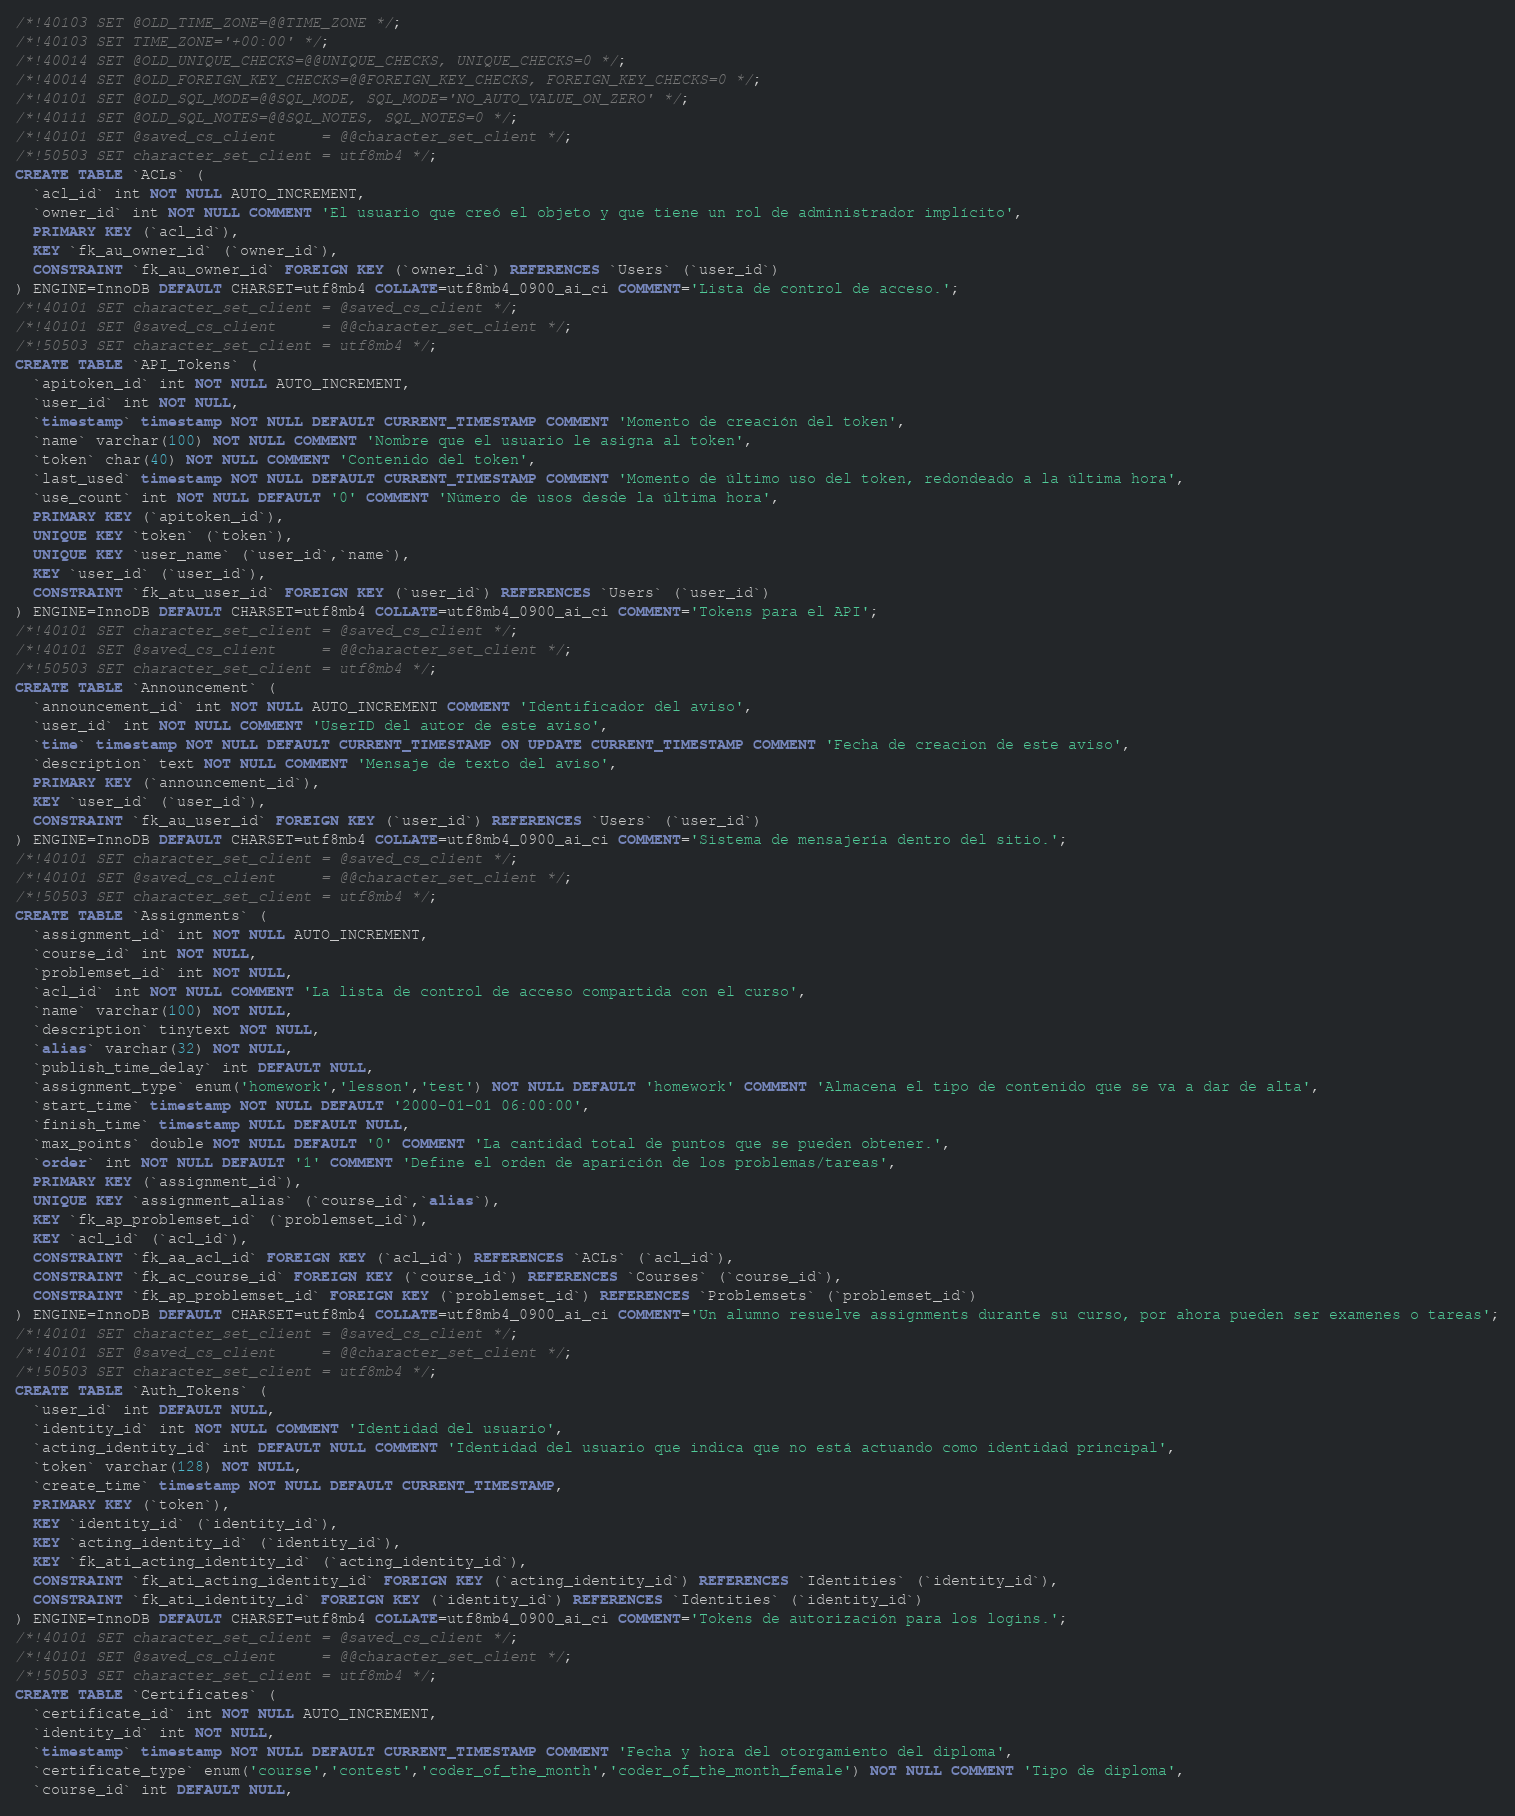Convert code to text. <code><loc_0><loc_0><loc_500><loc_500><_SQL_>/*!40103 SET @OLD_TIME_ZONE=@@TIME_ZONE */;
/*!40103 SET TIME_ZONE='+00:00' */;
/*!40014 SET @OLD_UNIQUE_CHECKS=@@UNIQUE_CHECKS, UNIQUE_CHECKS=0 */;
/*!40014 SET @OLD_FOREIGN_KEY_CHECKS=@@FOREIGN_KEY_CHECKS, FOREIGN_KEY_CHECKS=0 */;
/*!40101 SET @OLD_SQL_MODE=@@SQL_MODE, SQL_MODE='NO_AUTO_VALUE_ON_ZERO' */;
/*!40111 SET @OLD_SQL_NOTES=@@SQL_NOTES, SQL_NOTES=0 */;
/*!40101 SET @saved_cs_client     = @@character_set_client */;
/*!50503 SET character_set_client = utf8mb4 */;
CREATE TABLE `ACLs` (
  `acl_id` int NOT NULL AUTO_INCREMENT,
  `owner_id` int NOT NULL COMMENT 'El usuario que creó el objeto y que tiene un rol de administrador implícito',
  PRIMARY KEY (`acl_id`),
  KEY `fk_au_owner_id` (`owner_id`),
  CONSTRAINT `fk_au_owner_id` FOREIGN KEY (`owner_id`) REFERENCES `Users` (`user_id`)
) ENGINE=InnoDB DEFAULT CHARSET=utf8mb4 COLLATE=utf8mb4_0900_ai_ci COMMENT='Lista de control de acceso.';
/*!40101 SET character_set_client = @saved_cs_client */;
/*!40101 SET @saved_cs_client     = @@character_set_client */;
/*!50503 SET character_set_client = utf8mb4 */;
CREATE TABLE `API_Tokens` (
  `apitoken_id` int NOT NULL AUTO_INCREMENT,
  `user_id` int NOT NULL,
  `timestamp` timestamp NOT NULL DEFAULT CURRENT_TIMESTAMP COMMENT 'Momento de creación del token',
  `name` varchar(100) NOT NULL COMMENT 'Nombre que el usuario le asigna al token',
  `token` char(40) NOT NULL COMMENT 'Contenido del token',
  `last_used` timestamp NOT NULL DEFAULT CURRENT_TIMESTAMP COMMENT 'Momento de último uso del token, redondeado a la última hora',
  `use_count` int NOT NULL DEFAULT '0' COMMENT 'Número de usos desde la última hora',
  PRIMARY KEY (`apitoken_id`),
  UNIQUE KEY `token` (`token`),
  UNIQUE KEY `user_name` (`user_id`,`name`),
  KEY `user_id` (`user_id`),
  CONSTRAINT `fk_atu_user_id` FOREIGN KEY (`user_id`) REFERENCES `Users` (`user_id`)
) ENGINE=InnoDB DEFAULT CHARSET=utf8mb4 COLLATE=utf8mb4_0900_ai_ci COMMENT='Tokens para el API';
/*!40101 SET character_set_client = @saved_cs_client */;
/*!40101 SET @saved_cs_client     = @@character_set_client */;
/*!50503 SET character_set_client = utf8mb4 */;
CREATE TABLE `Announcement` (
  `announcement_id` int NOT NULL AUTO_INCREMENT COMMENT 'Identificador del aviso',
  `user_id` int NOT NULL COMMENT 'UserID del autor de este aviso',
  `time` timestamp NOT NULL DEFAULT CURRENT_TIMESTAMP ON UPDATE CURRENT_TIMESTAMP COMMENT 'Fecha de creacion de este aviso',
  `description` text NOT NULL COMMENT 'Mensaje de texto del aviso',
  PRIMARY KEY (`announcement_id`),
  KEY `user_id` (`user_id`),
  CONSTRAINT `fk_au_user_id` FOREIGN KEY (`user_id`) REFERENCES `Users` (`user_id`)
) ENGINE=InnoDB DEFAULT CHARSET=utf8mb4 COLLATE=utf8mb4_0900_ai_ci COMMENT='Sistema de mensajería dentro del sitio.';
/*!40101 SET character_set_client = @saved_cs_client */;
/*!40101 SET @saved_cs_client     = @@character_set_client */;
/*!50503 SET character_set_client = utf8mb4 */;
CREATE TABLE `Assignments` (
  `assignment_id` int NOT NULL AUTO_INCREMENT,
  `course_id` int NOT NULL,
  `problemset_id` int NOT NULL,
  `acl_id` int NOT NULL COMMENT 'La lista de control de acceso compartida con el curso',
  `name` varchar(100) NOT NULL,
  `description` tinytext NOT NULL,
  `alias` varchar(32) NOT NULL,
  `publish_time_delay` int DEFAULT NULL,
  `assignment_type` enum('homework','lesson','test') NOT NULL DEFAULT 'homework' COMMENT 'Almacena el tipo de contenido que se va a dar de alta',
  `start_time` timestamp NOT NULL DEFAULT '2000-01-01 06:00:00',
  `finish_time` timestamp NULL DEFAULT NULL,
  `max_points` double NOT NULL DEFAULT '0' COMMENT 'La cantidad total de puntos que se pueden obtener.',
  `order` int NOT NULL DEFAULT '1' COMMENT 'Define el orden de aparición de los problemas/tareas',
  PRIMARY KEY (`assignment_id`),
  UNIQUE KEY `assignment_alias` (`course_id`,`alias`),
  KEY `fk_ap_problemset_id` (`problemset_id`),
  KEY `acl_id` (`acl_id`),
  CONSTRAINT `fk_aa_acl_id` FOREIGN KEY (`acl_id`) REFERENCES `ACLs` (`acl_id`),
  CONSTRAINT `fk_ac_course_id` FOREIGN KEY (`course_id`) REFERENCES `Courses` (`course_id`),
  CONSTRAINT `fk_ap_problemset_id` FOREIGN KEY (`problemset_id`) REFERENCES `Problemsets` (`problemset_id`)
) ENGINE=InnoDB DEFAULT CHARSET=utf8mb4 COLLATE=utf8mb4_0900_ai_ci COMMENT='Un alumno resuelve assignments durante su curso, por ahora pueden ser examenes o tareas';
/*!40101 SET character_set_client = @saved_cs_client */;
/*!40101 SET @saved_cs_client     = @@character_set_client */;
/*!50503 SET character_set_client = utf8mb4 */;
CREATE TABLE `Auth_Tokens` (
  `user_id` int DEFAULT NULL,
  `identity_id` int NOT NULL COMMENT 'Identidad del usuario',
  `acting_identity_id` int DEFAULT NULL COMMENT 'Identidad del usuario que indica que no está actuando como identidad principal',
  `token` varchar(128) NOT NULL,
  `create_time` timestamp NOT NULL DEFAULT CURRENT_TIMESTAMP,
  PRIMARY KEY (`token`),
  KEY `identity_id` (`identity_id`),
  KEY `acting_identity_id` (`identity_id`),
  KEY `fk_ati_acting_identity_id` (`acting_identity_id`),
  CONSTRAINT `fk_ati_acting_identity_id` FOREIGN KEY (`acting_identity_id`) REFERENCES `Identities` (`identity_id`),
  CONSTRAINT `fk_ati_identity_id` FOREIGN KEY (`identity_id`) REFERENCES `Identities` (`identity_id`)
) ENGINE=InnoDB DEFAULT CHARSET=utf8mb4 COLLATE=utf8mb4_0900_ai_ci COMMENT='Tokens de autorización para los logins.';
/*!40101 SET character_set_client = @saved_cs_client */;
/*!40101 SET @saved_cs_client     = @@character_set_client */;
/*!50503 SET character_set_client = utf8mb4 */;
CREATE TABLE `Certificates` (
  `certificate_id` int NOT NULL AUTO_INCREMENT,
  `identity_id` int NOT NULL,
  `timestamp` timestamp NOT NULL DEFAULT CURRENT_TIMESTAMP COMMENT 'Fecha y hora del otorgamiento del diploma',
  `certificate_type` enum('course','contest','coder_of_the_month','coder_of_the_month_female') NOT NULL COMMENT 'Tipo de diploma',
  `course_id` int DEFAULT NULL,</code> 